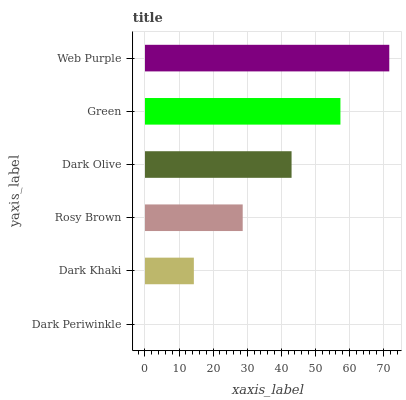Is Dark Periwinkle the minimum?
Answer yes or no. Yes. Is Web Purple the maximum?
Answer yes or no. Yes. Is Dark Khaki the minimum?
Answer yes or no. No. Is Dark Khaki the maximum?
Answer yes or no. No. Is Dark Khaki greater than Dark Periwinkle?
Answer yes or no. Yes. Is Dark Periwinkle less than Dark Khaki?
Answer yes or no. Yes. Is Dark Periwinkle greater than Dark Khaki?
Answer yes or no. No. Is Dark Khaki less than Dark Periwinkle?
Answer yes or no. No. Is Dark Olive the high median?
Answer yes or no. Yes. Is Rosy Brown the low median?
Answer yes or no. Yes. Is Web Purple the high median?
Answer yes or no. No. Is Green the low median?
Answer yes or no. No. 